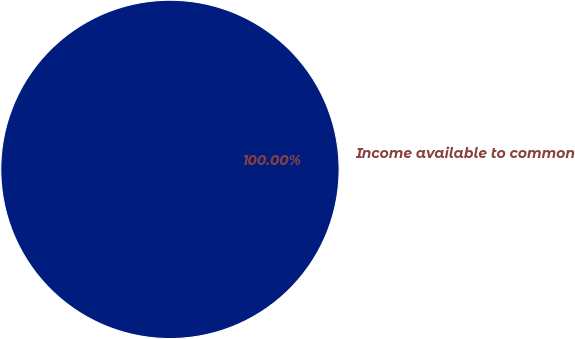<chart> <loc_0><loc_0><loc_500><loc_500><pie_chart><fcel>Income available to common<nl><fcel>100.0%<nl></chart> 